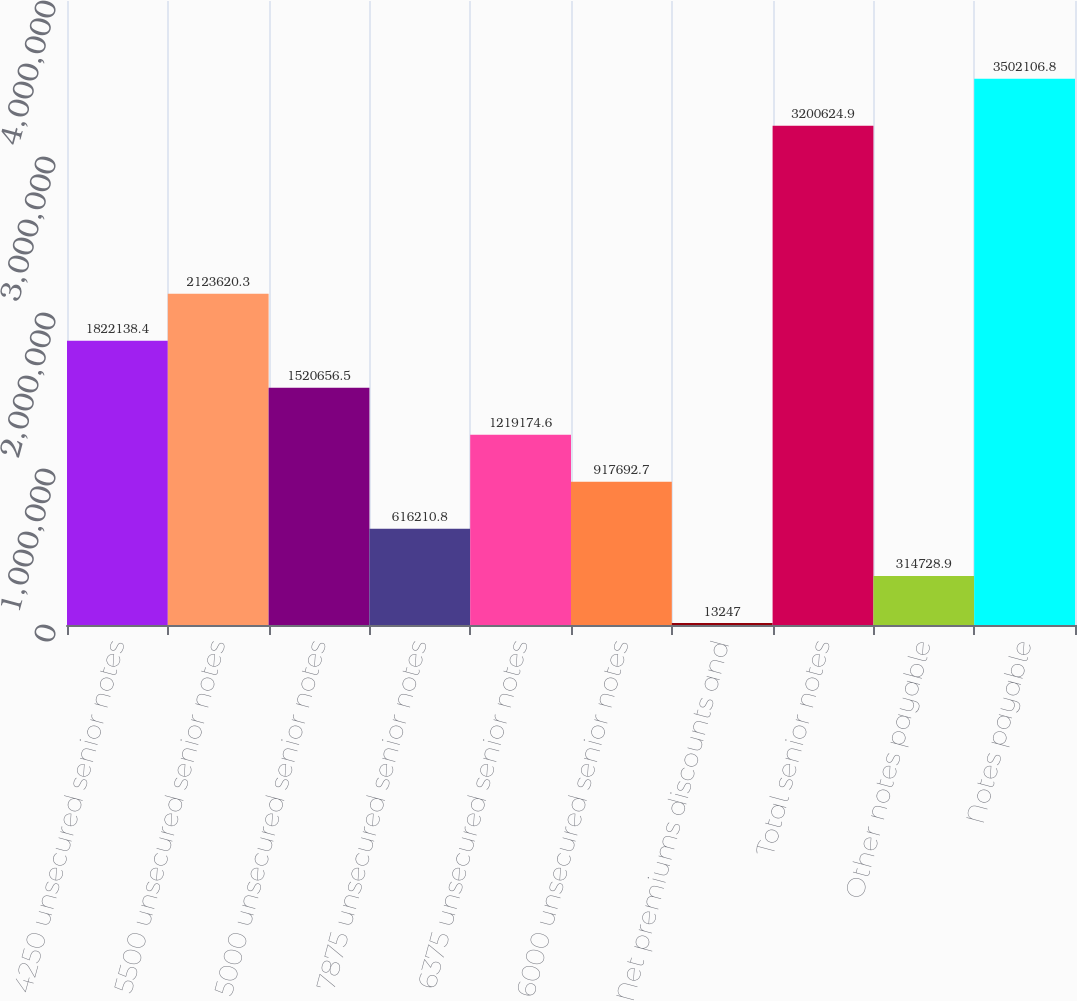<chart> <loc_0><loc_0><loc_500><loc_500><bar_chart><fcel>4250 unsecured senior notes<fcel>5500 unsecured senior notes<fcel>5000 unsecured senior notes<fcel>7875 unsecured senior notes<fcel>6375 unsecured senior notes<fcel>6000 unsecured senior notes<fcel>Net premiums discounts and<fcel>Total senior notes<fcel>Other notes payable<fcel>Notes payable<nl><fcel>1.82214e+06<fcel>2.12362e+06<fcel>1.52066e+06<fcel>616211<fcel>1.21917e+06<fcel>917693<fcel>13247<fcel>3.20062e+06<fcel>314729<fcel>3.50211e+06<nl></chart> 